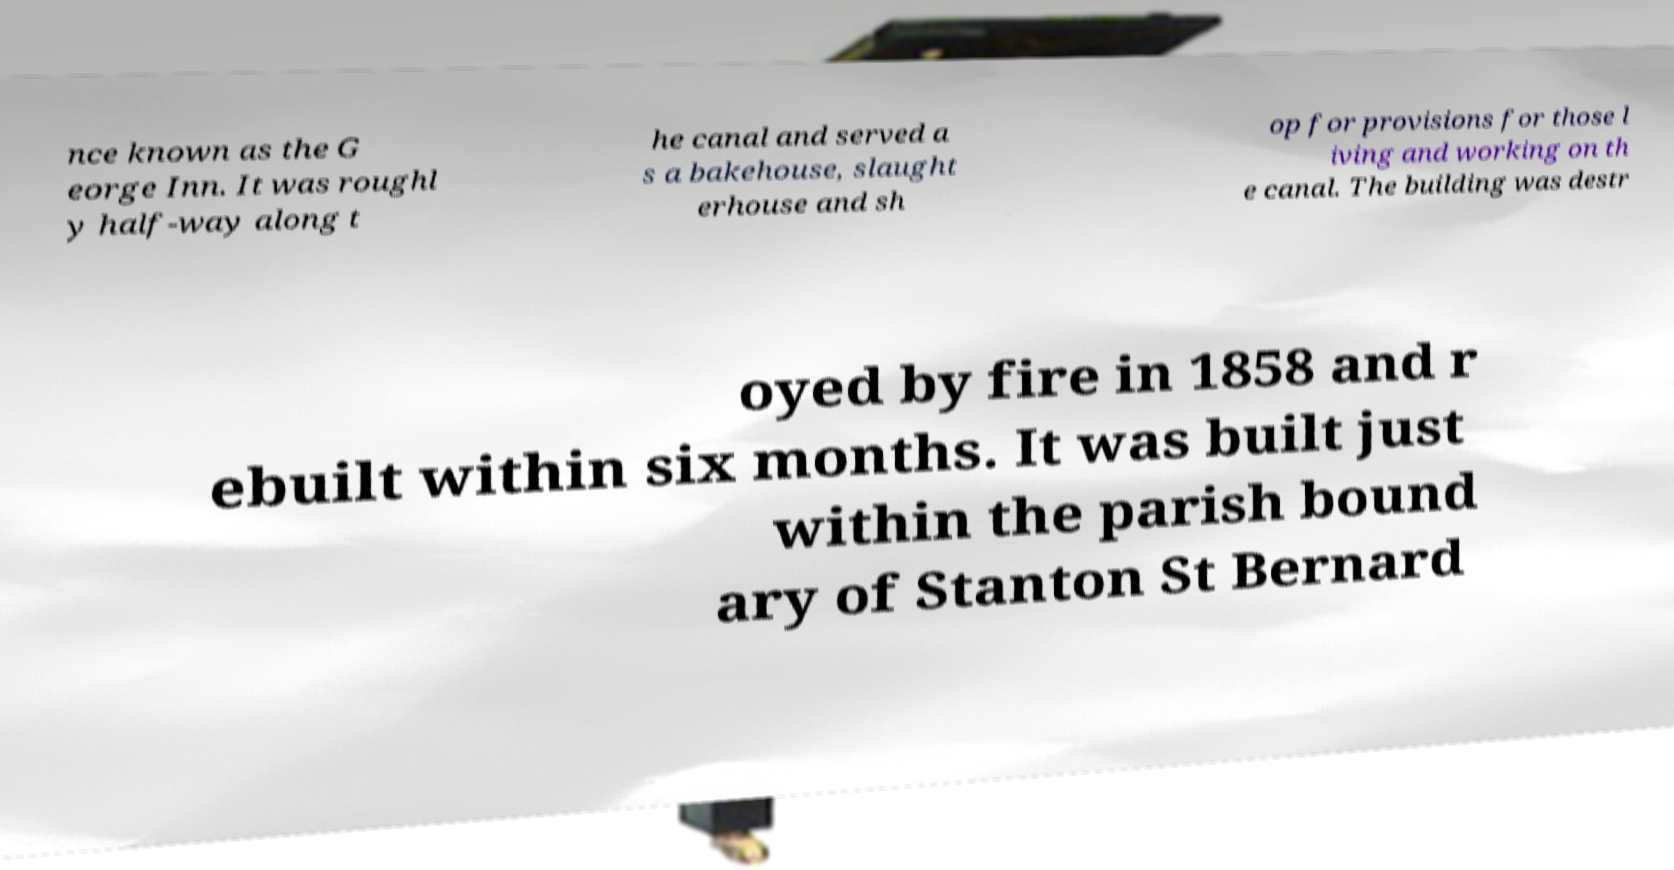There's text embedded in this image that I need extracted. Can you transcribe it verbatim? nce known as the G eorge Inn. It was roughl y half-way along t he canal and served a s a bakehouse, slaught erhouse and sh op for provisions for those l iving and working on th e canal. The building was destr oyed by fire in 1858 and r ebuilt within six months. It was built just within the parish bound ary of Stanton St Bernard 